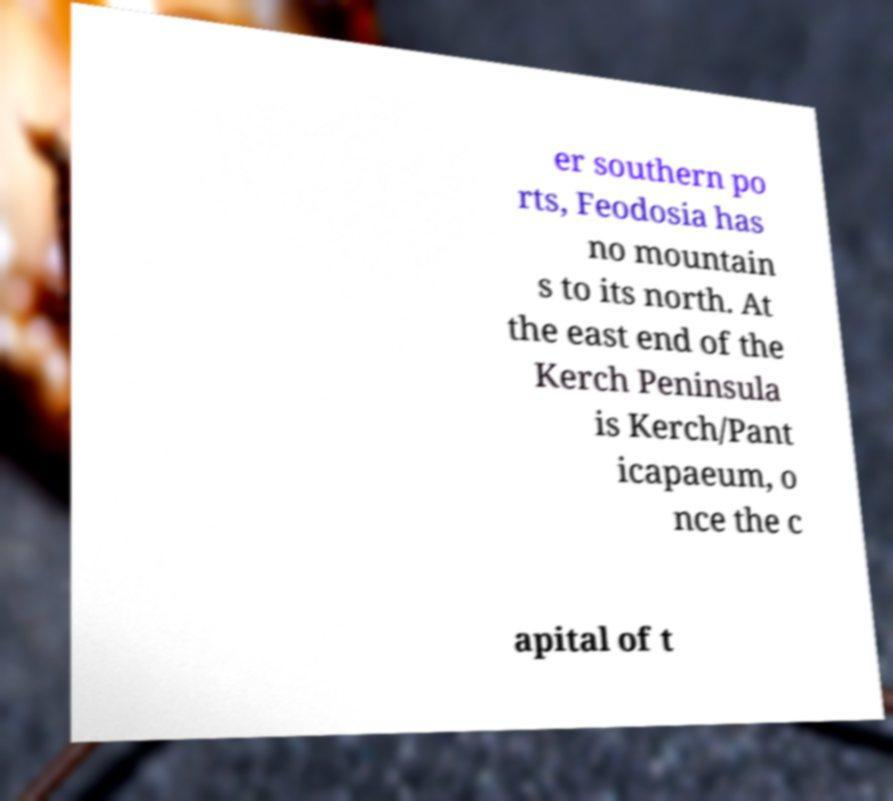Please read and relay the text visible in this image. What does it say? er southern po rts, Feodosia has no mountain s to its north. At the east end of the Kerch Peninsula is Kerch/Pant icapaeum, o nce the c apital of t 